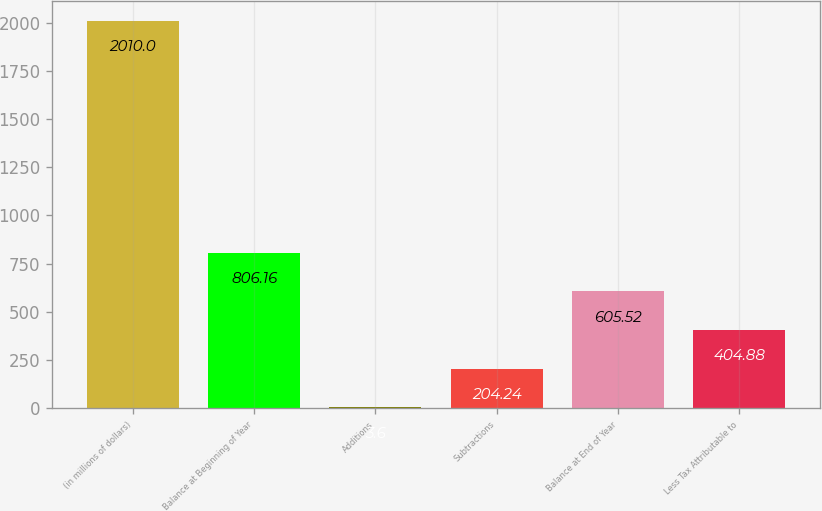<chart> <loc_0><loc_0><loc_500><loc_500><bar_chart><fcel>(in millions of dollars)<fcel>Balance at Beginning of Year<fcel>Additions<fcel>Subtractions<fcel>Balance at End of Year<fcel>Less Tax Attributable to<nl><fcel>2010<fcel>806.16<fcel>3.6<fcel>204.24<fcel>605.52<fcel>404.88<nl></chart> 